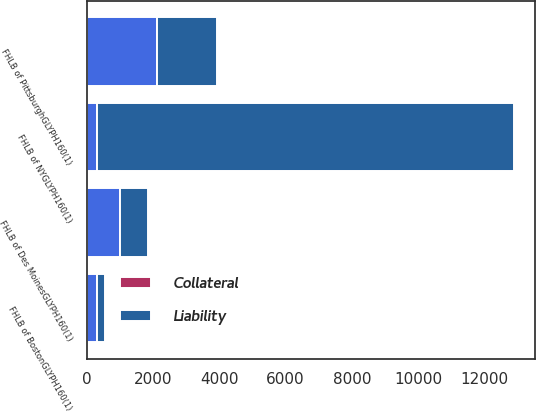<chart> <loc_0><loc_0><loc_500><loc_500><stacked_bar_chart><ecel><fcel>FHLB of NYGLYPH160(1)<fcel>FHLB of Des MoinesGLYPH160(1)<fcel>FHLB of BostonGLYPH160(1)<fcel>FHLB of PittsburghGLYPH160(1)<nl><fcel>Liability<fcel>12570<fcel>845<fcel>250<fcel>1820<nl><fcel>nan<fcel>311<fcel>999<fcel>311<fcel>2112<nl><fcel>Collateral<fcel>2<fcel>2<fcel>2<fcel>2<nl></chart> 